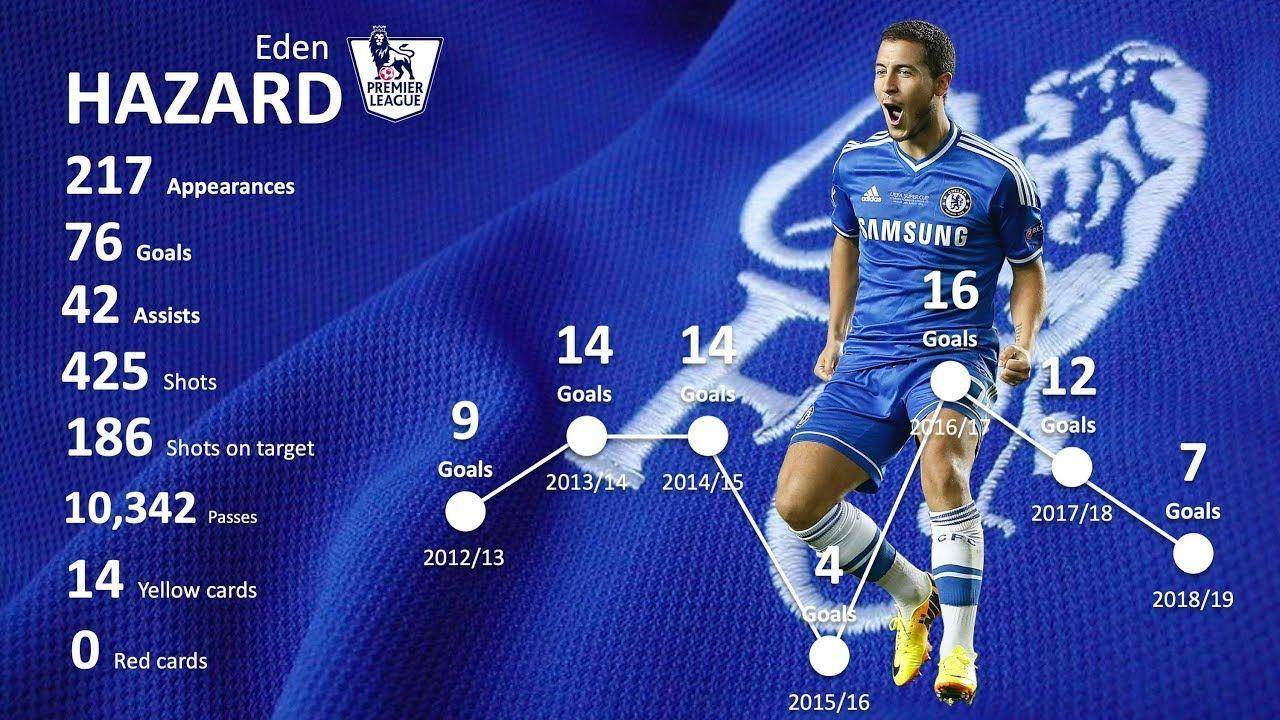What is the colour of the player's shoe- yellow, blue or white?
Answer the question with a short phrase. Yellow What is the player's jersey colour- white, yellow or blue? blue 